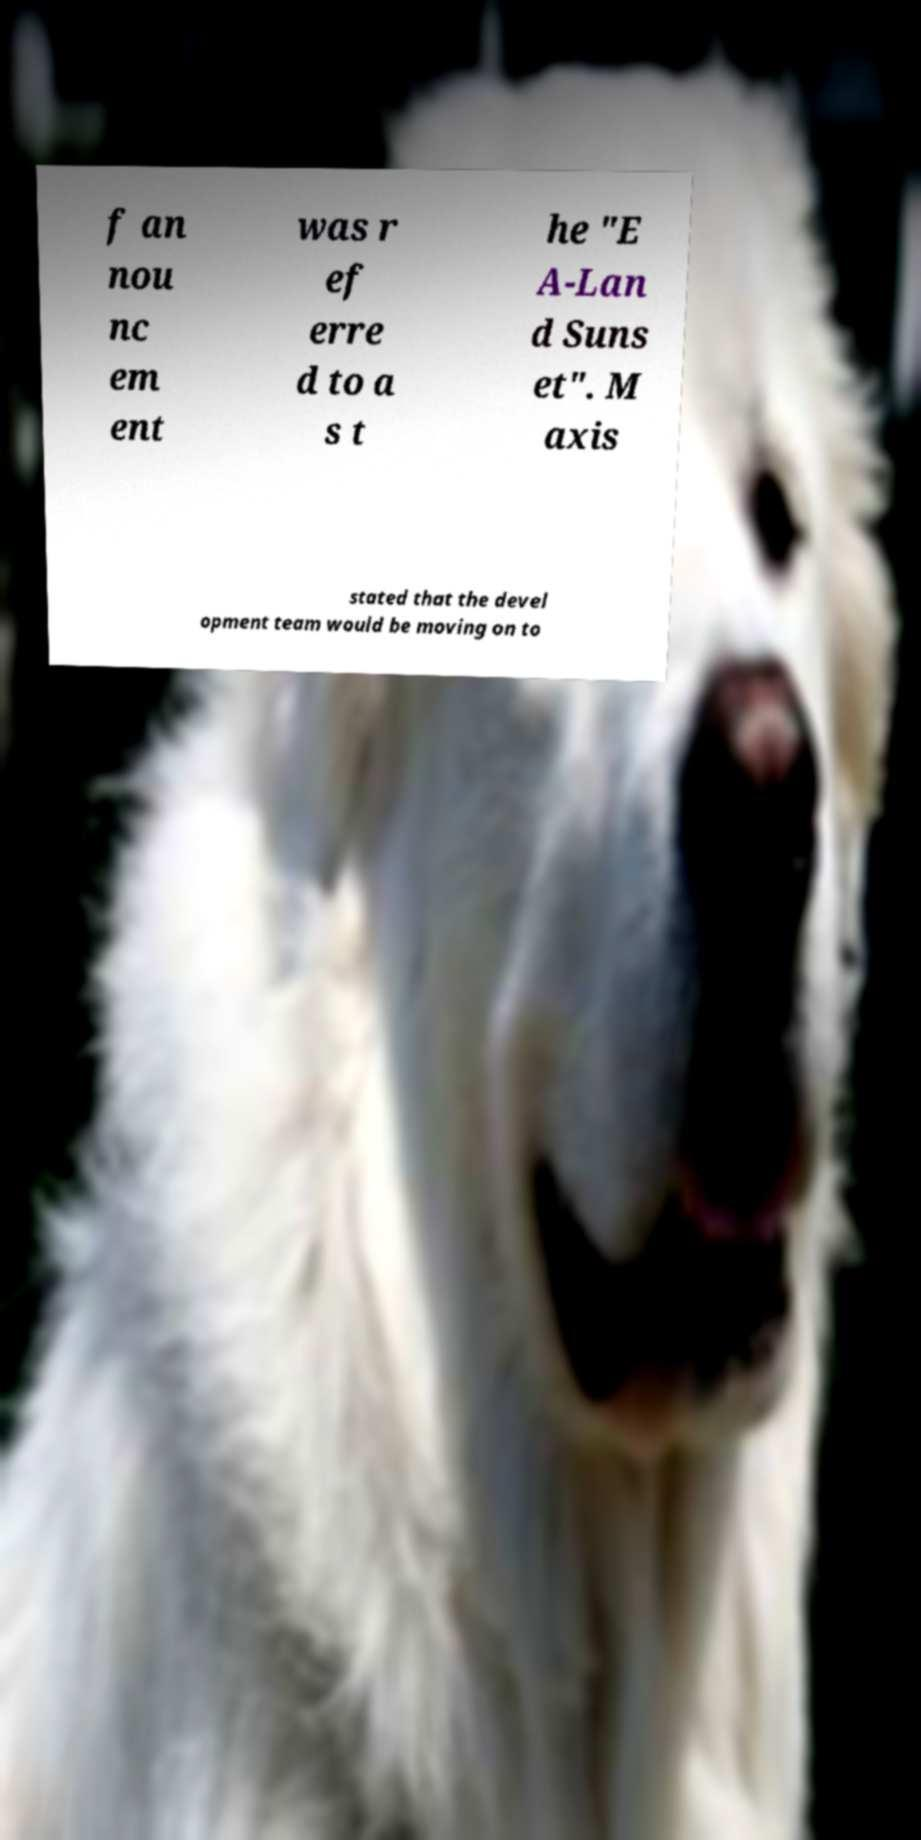Could you extract and type out the text from this image? f an nou nc em ent was r ef erre d to a s t he "E A-Lan d Suns et". M axis stated that the devel opment team would be moving on to 